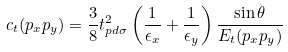<formula> <loc_0><loc_0><loc_500><loc_500>c _ { t } ( p _ { x } p _ { y } ) = \frac { 3 } { 8 } t _ { p d \sigma } ^ { 2 } \left ( \frac { 1 } { \epsilon _ { x } } + \frac { 1 } { \epsilon _ { y } } \right ) \frac { \sin \theta } { E _ { t } ( p _ { x } p _ { y } ) }</formula> 